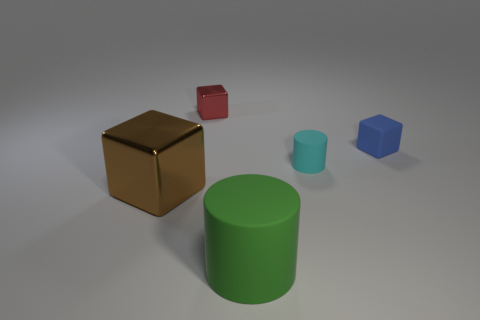What number of other things are there of the same material as the large block
Offer a very short reply. 1. Are there fewer small cyan blocks than tiny cylinders?
Ensure brevity in your answer.  Yes. There is a green matte cylinder; is its size the same as the metallic block that is on the right side of the big metallic cube?
Your answer should be very brief. No. Is there any other thing that is the same shape as the big green thing?
Provide a succinct answer. Yes. The blue thing has what size?
Your response must be concise. Small. Is the number of large shiny objects that are behind the blue matte thing less than the number of big brown metallic things?
Give a very brief answer. Yes. Is the red metal cube the same size as the cyan object?
Your answer should be compact. Yes. Is there anything else that is the same size as the red metallic object?
Make the answer very short. Yes. What is the color of the other small thing that is the same material as the blue thing?
Offer a very short reply. Cyan. Is the number of large cubes to the left of the green rubber cylinder less than the number of green objects to the right of the small blue object?
Your response must be concise. No. 